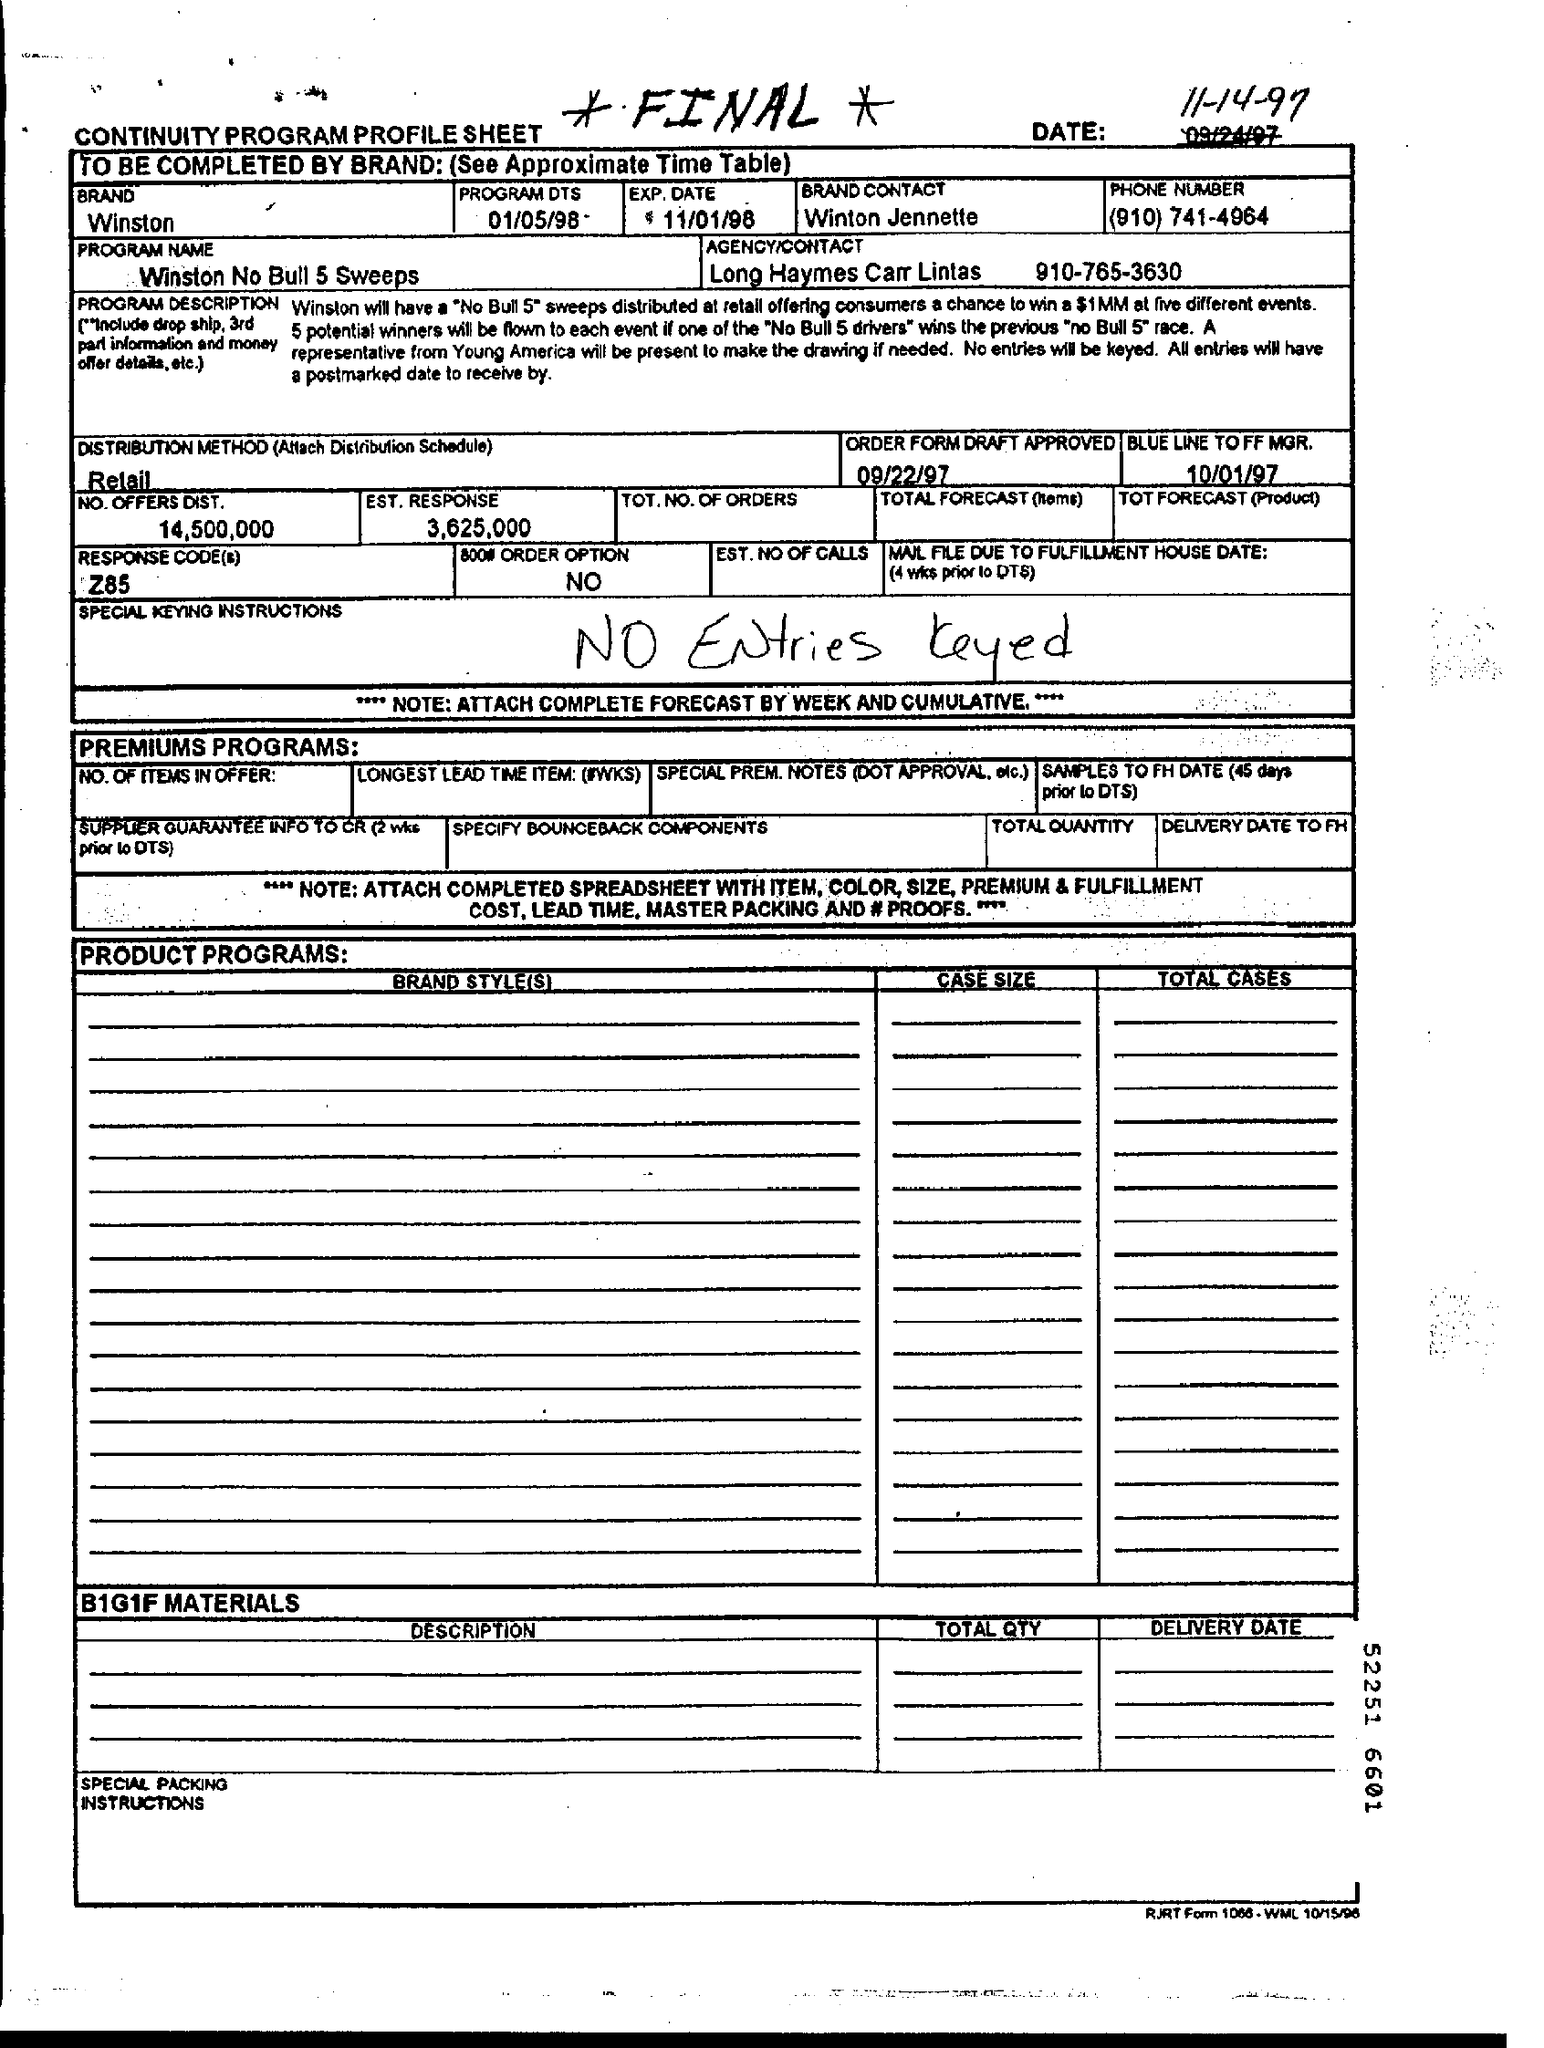Specify some key components in this picture. The estimated response is 3,625,000, as per the provided document. The brand mentioned in this document is Winston. Winton Jennette is the brand contact person. The distribution method used is retail. The document mentions an expiration date of 11/01/98. 